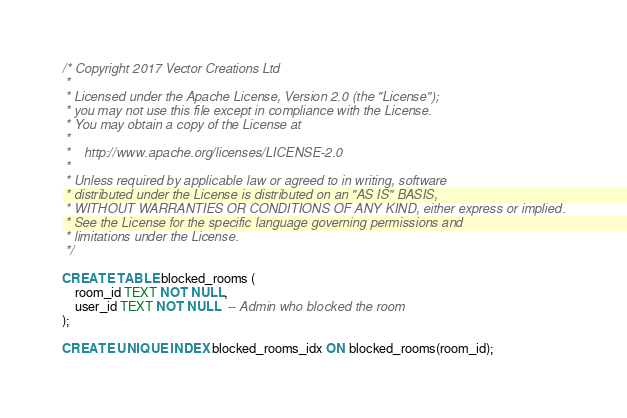<code> <loc_0><loc_0><loc_500><loc_500><_SQL_>/* Copyright 2017 Vector Creations Ltd
 *
 * Licensed under the Apache License, Version 2.0 (the "License");
 * you may not use this file except in compliance with the License.
 * You may obtain a copy of the License at
 *
 *    http://www.apache.org/licenses/LICENSE-2.0
 *
 * Unless required by applicable law or agreed to in writing, software
 * distributed under the License is distributed on an "AS IS" BASIS,
 * WITHOUT WARRANTIES OR CONDITIONS OF ANY KIND, either express or implied.
 * See the License for the specific language governing permissions and
 * limitations under the License.
 */

CREATE TABLE blocked_rooms (
    room_id TEXT NOT NULL,
    user_id TEXT NOT NULL  -- Admin who blocked the room
);

CREATE UNIQUE INDEX blocked_rooms_idx ON blocked_rooms(room_id);
</code> 